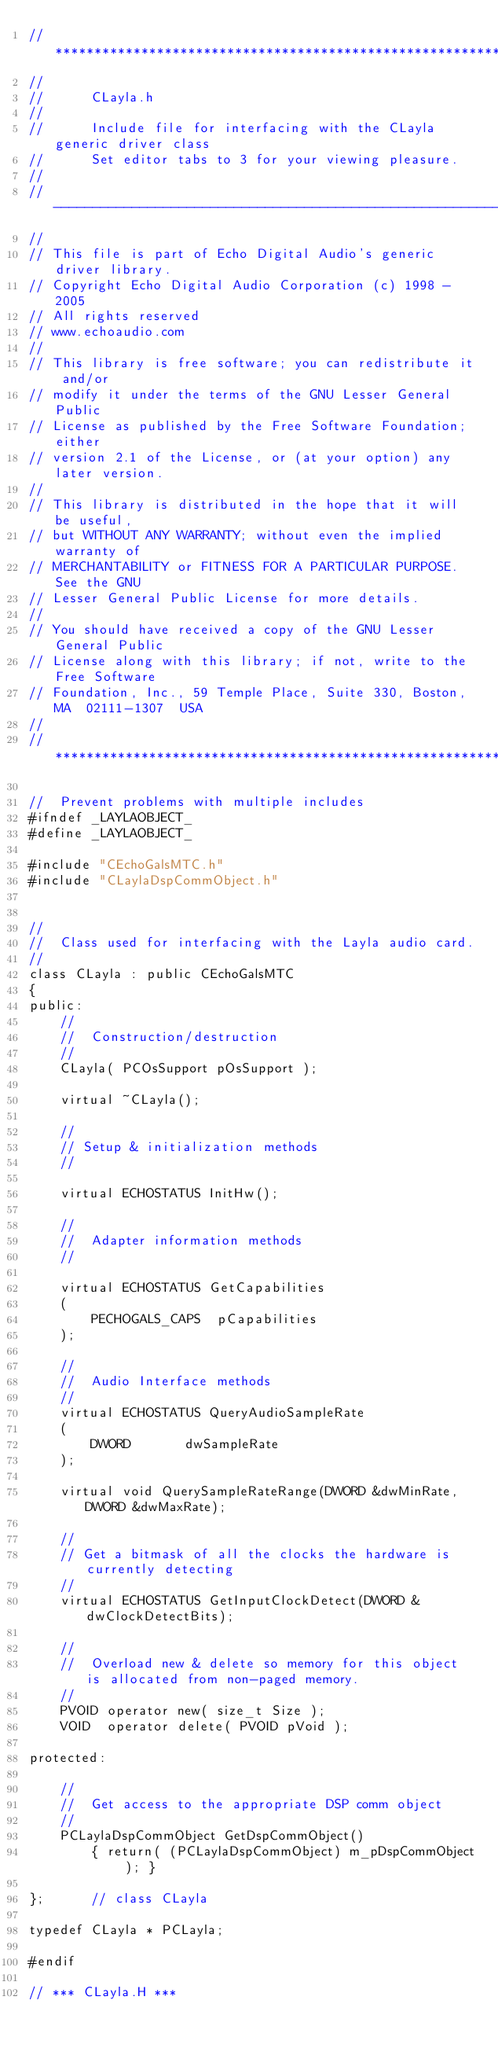Convert code to text. <code><loc_0><loc_0><loc_500><loc_500><_C_>// ****************************************************************************
//
//		CLayla.h
//
//		Include file for interfacing with the CLayla generic driver class
//		Set editor tabs to 3 for your viewing pleasure.
//
// ----------------------------------------------------------------------------
//
// This file is part of Echo Digital Audio's generic driver library.
// Copyright Echo Digital Audio Corporation (c) 1998 - 2005
// All rights reserved
// www.echoaudio.com
//
// This library is free software; you can redistribute it and/or
// modify it under the terms of the GNU Lesser General Public
// License as published by the Free Software Foundation; either
// version 2.1 of the License, or (at your option) any later version.
//
// This library is distributed in the hope that it will be useful,
// but WITHOUT ANY WARRANTY; without even the implied warranty of
// MERCHANTABILITY or FITNESS FOR A PARTICULAR PURPOSE.  See the GNU
// Lesser General Public License for more details.
//
// You should have received a copy of the GNU Lesser General Public
// License along with this library; if not, write to the Free Software
// Foundation, Inc., 59 Temple Place, Suite 330, Boston, MA  02111-1307  USA
//
// ****************************************************************************

//	Prevent problems with multiple includes
#ifndef _LAYLAOBJECT_
#define _LAYLAOBJECT_

#include "CEchoGalsMTC.h"
#include "CLaylaDspCommObject.h"


//
//	Class used for interfacing with the Layla audio card.
//
class CLayla : public CEchoGalsMTC
{
public:
	//
	//	Construction/destruction
	//
	CLayla( PCOsSupport pOsSupport );

	virtual ~CLayla();

	//
	// Setup & initialization methods
	//

	virtual ECHOSTATUS InitHw();

	//
	//	Adapter information methods
	//

	virtual ECHOSTATUS GetCapabilities
	(
		PECHOGALS_CAPS	pCapabilities
	);

	//
	//	Audio Interface methods
	//
	virtual ECHOSTATUS QueryAudioSampleRate
	(
		DWORD		dwSampleRate
	);
	
	virtual void QuerySampleRateRange(DWORD &dwMinRate,DWORD &dwMaxRate);

	//
	// Get a bitmask of all the clocks the hardware is currently detecting
	//
	virtual ECHOSTATUS GetInputClockDetect(DWORD &dwClockDetectBits);
	
	//
	//  Overload new & delete so memory for this object is allocated from non-paged memory.
	//
	PVOID operator new( size_t Size );
	VOID  operator delete( PVOID pVoid ); 

protected:

	//
	//	Get access to the appropriate DSP comm object
	//
	PCLaylaDspCommObject GetDspCommObject()
		{ return( (PCLaylaDspCommObject) m_pDspCommObject ); }

};		// class CLayla

typedef CLayla * PCLayla;

#endif

// *** CLayla.H ***
</code> 